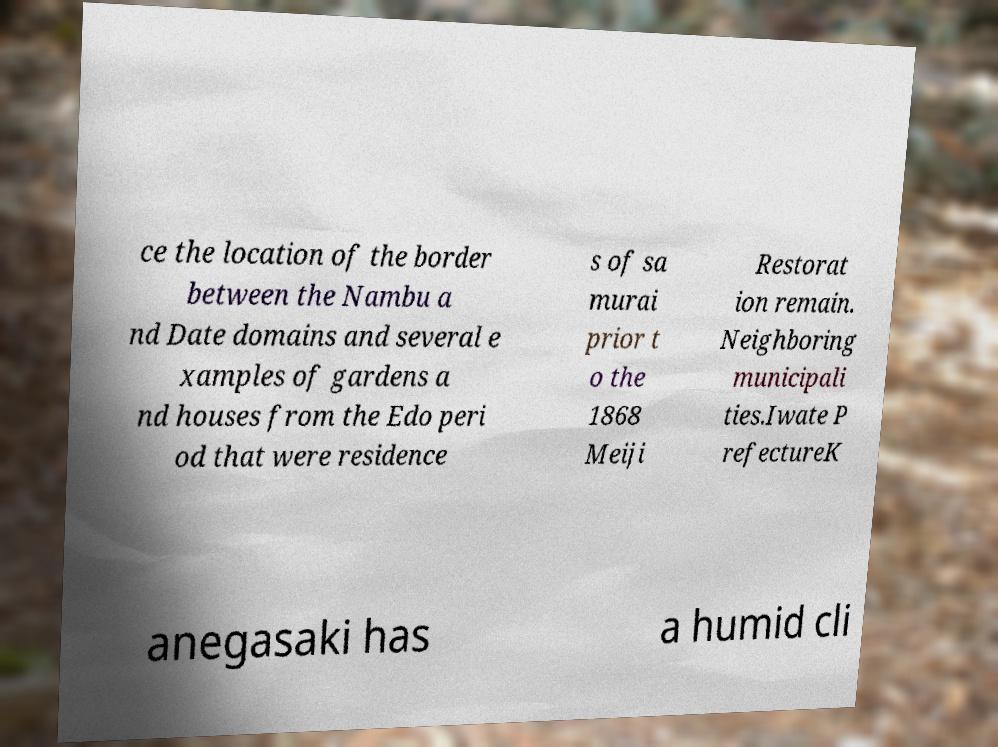Please identify and transcribe the text found in this image. ce the location of the border between the Nambu a nd Date domains and several e xamples of gardens a nd houses from the Edo peri od that were residence s of sa murai prior t o the 1868 Meiji Restorat ion remain. Neighboring municipali ties.Iwate P refectureK anegasaki has a humid cli 